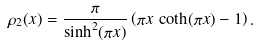Convert formula to latex. <formula><loc_0><loc_0><loc_500><loc_500>\rho _ { 2 } ( x ) = \frac { \pi } { \sinh ^ { 2 } ( \pi x ) } \left ( \pi x \, \coth ( \pi x ) - 1 \right ) .</formula> 